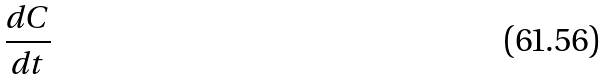Convert formula to latex. <formula><loc_0><loc_0><loc_500><loc_500>\frac { d C } { d t }</formula> 